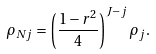Convert formula to latex. <formula><loc_0><loc_0><loc_500><loc_500>\rho _ { N j } = \left ( \frac { 1 - r ^ { 2 } } { 4 } \right ) ^ { J - j } \rho _ { j } .</formula> 